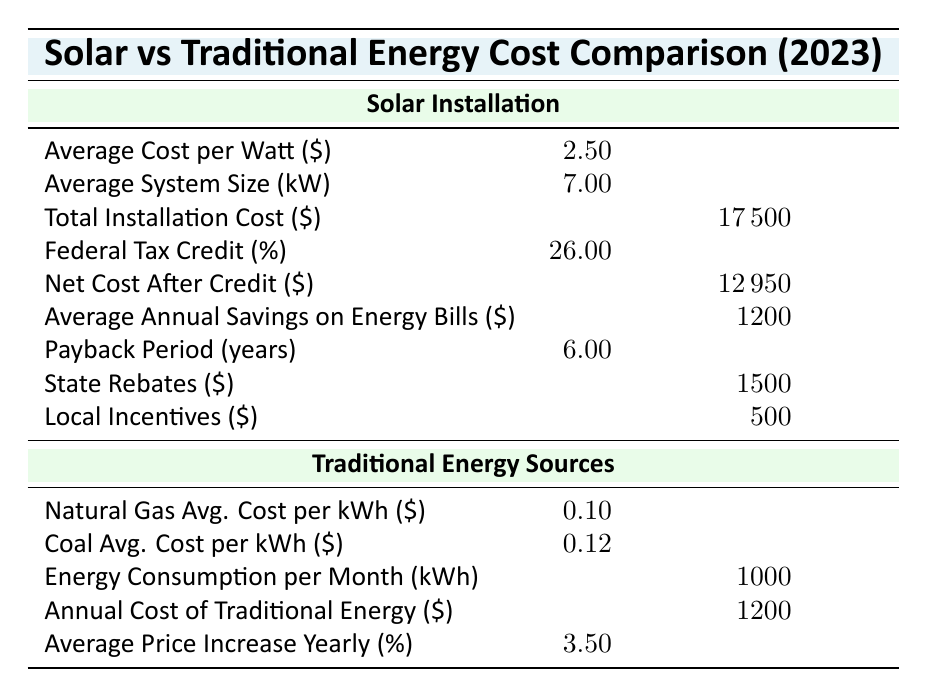What is the average cost per watt for solar installation? The table specifies the average cost per watt for solar installation as 2.50. There is no need for additional calculations as the value is directly provided.
Answer: 2.50 What is the total installation cost for solar panels? The total installation cost for solar panels is explicitly stated in the table as 17500. This value is provided directly without further calculations needed.
Answer: 17500 How much is the federal tax credit for solar installation? The table indicates that the federal tax credit for solar installation is 26.00%. This fact is directly mentioned in the corresponding row of the table.
Answer: 26.00% What is the payback period for solar installation in years? According to the table, the payback period for solar installation is 6.00 years. This information is given directly and does not require further analysis.
Answer: 6.00 What is the annual cost of traditional energy sources? The table shows that the annual cost of traditional energy sources is 1200. This value can be found in the respective row for traditional energy.
Answer: 1200 What is the average annual savings on energy bills for solar installation? The average annual savings on energy bills provided for solar installations is 1200. This information is clearly stated in the table, making it easy to retrieve.
Answer: 1200 If the average price of traditional energy increases by 3.5% annually, what would the annual cost be in 5 years? First, the current annual cost of traditional energy is 1200. We can calculate the future cost using the formula for compound interest: Future Cost = Present Cost × (1 + Rate)^Years. Here, that would be 1200 × (1 + 0.035)^5, which equals approximately 1200 × 1.1887 = 1426.44. So, the estimated cost in 5 years is 1426.44.
Answer: 1426.44 Is the average cost per watt for solar installation higher than the average cost per kWh for natural gas? The average cost per watt for solar installation is 2.50, while the average cost per kWh for natural gas is 0.10. Since 2.50 > 0.10, this statement is true.
Answer: Yes How much are the total state and local incentives combined for solar installation? The table lists state rebates as 1500 and local incentives as 500. To find the total, simply add these two amounts: 1500 + 500 = 2000. Thus, combined incentives total 2000.
Answer: 2000 